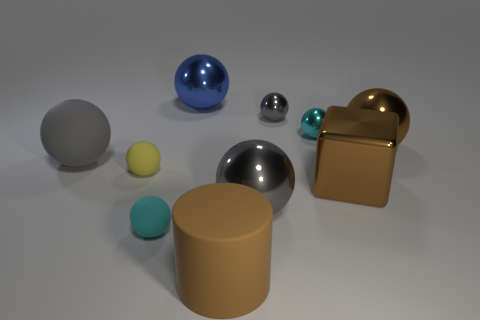How many brown rubber cylinders are the same size as the brown cube?
Your response must be concise. 1. What is the color of the big ball that is both to the right of the gray matte ball and in front of the large brown metallic ball?
Offer a terse response. Gray. How many things are either large brown rubber cylinders or blue metallic things?
Ensure brevity in your answer.  2. What number of tiny objects are either red metallic blocks or cyan balls?
Give a very brief answer. 2. Is there any other thing that has the same color as the metallic cube?
Offer a very short reply. Yes. What size is the gray ball that is both to the left of the small gray metal object and behind the brown shiny block?
Your response must be concise. Large. There is a small ball that is behind the tiny cyan shiny object; does it have the same color as the large metallic thing behind the brown ball?
Your response must be concise. No. What number of other things are the same material as the brown cube?
Offer a terse response. 5. What shape is the thing that is both in front of the big brown shiny cube and to the left of the blue object?
Your answer should be very brief. Sphere. Does the large metal cube have the same color as the large metallic object behind the big brown metal sphere?
Keep it short and to the point. No. 